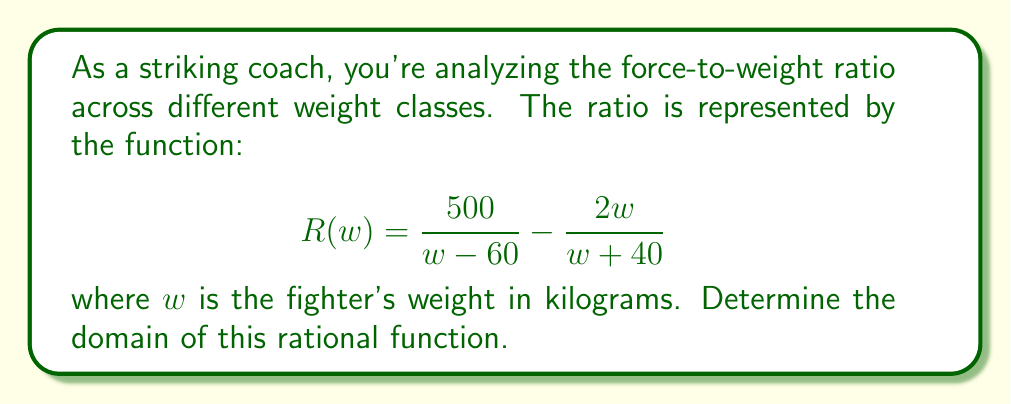What is the answer to this math problem? To find the domain of this rational function, we need to consider where the function is undefined. A rational function is undefined when its denominator equals zero. Let's analyze each part of the function:

1) For the first fraction $\frac{500}{w - 60}$:
   The denominator is zero when $w - 60 = 0$, or $w = 60$.

2) For the second fraction $-\frac{2w}{w + 40}$:
   The denominator is zero when $w + 40 = 0$, or $w = -40$.

3) The domain will exclude these values where the denominators are zero.

4) Additionally, since we're dealing with a fighter's weight, $w$ must be positive and realistically greater than 0.

5) Therefore, the domain is all real numbers greater than 60, excluding 60 itself.

In interval notation, this can be written as $(60, \infty)$.
Answer: $(60, \infty)$ 